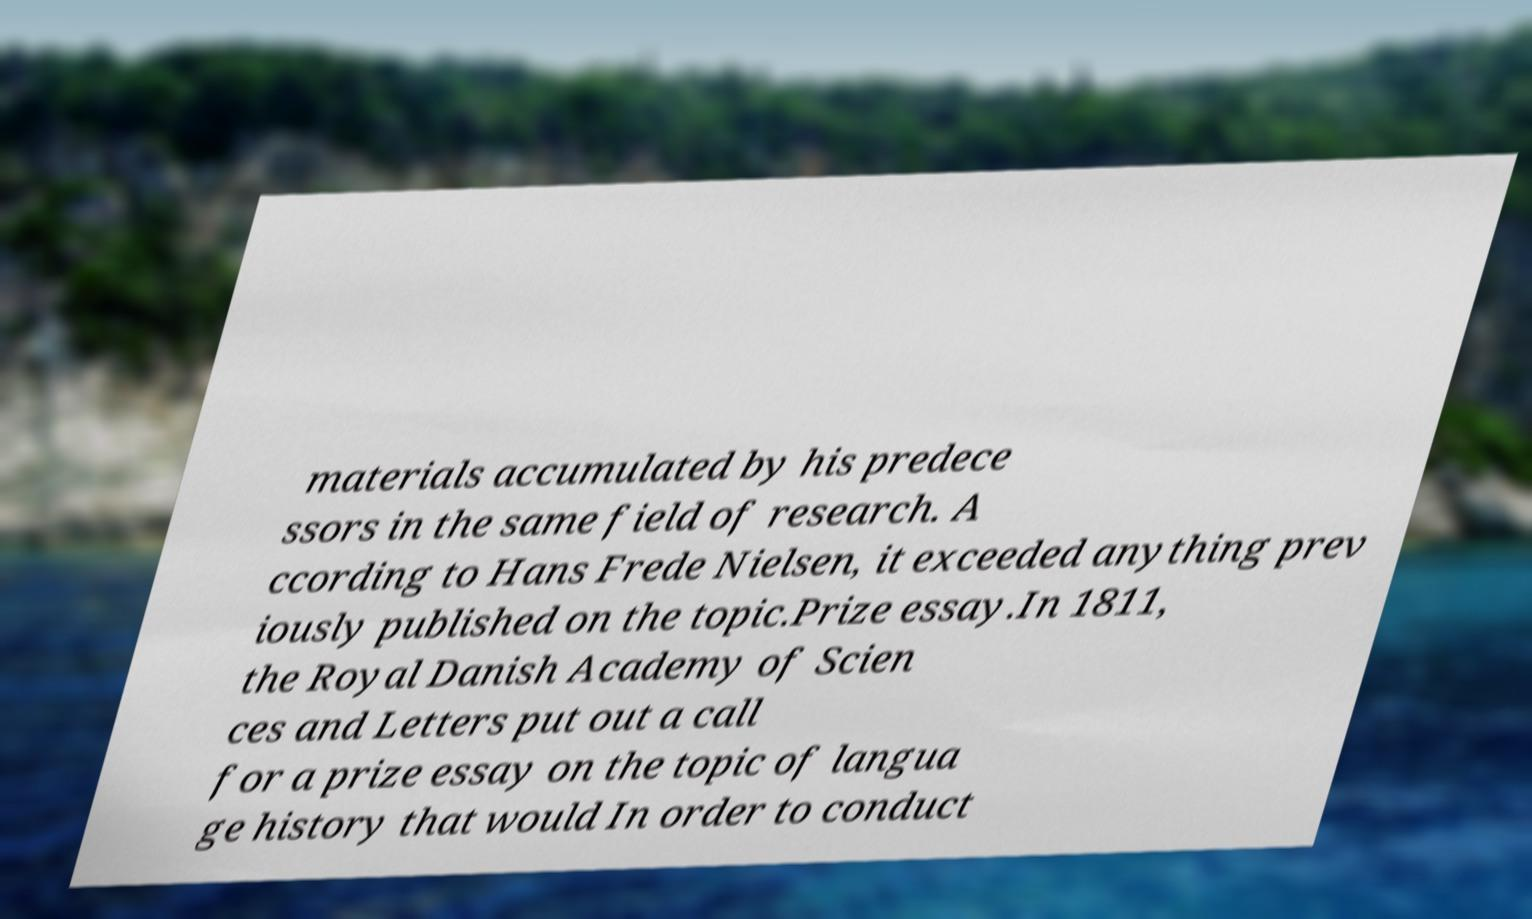Please identify and transcribe the text found in this image. materials accumulated by his predece ssors in the same field of research. A ccording to Hans Frede Nielsen, it exceeded anything prev iously published on the topic.Prize essay.In 1811, the Royal Danish Academy of Scien ces and Letters put out a call for a prize essay on the topic of langua ge history that would In order to conduct 